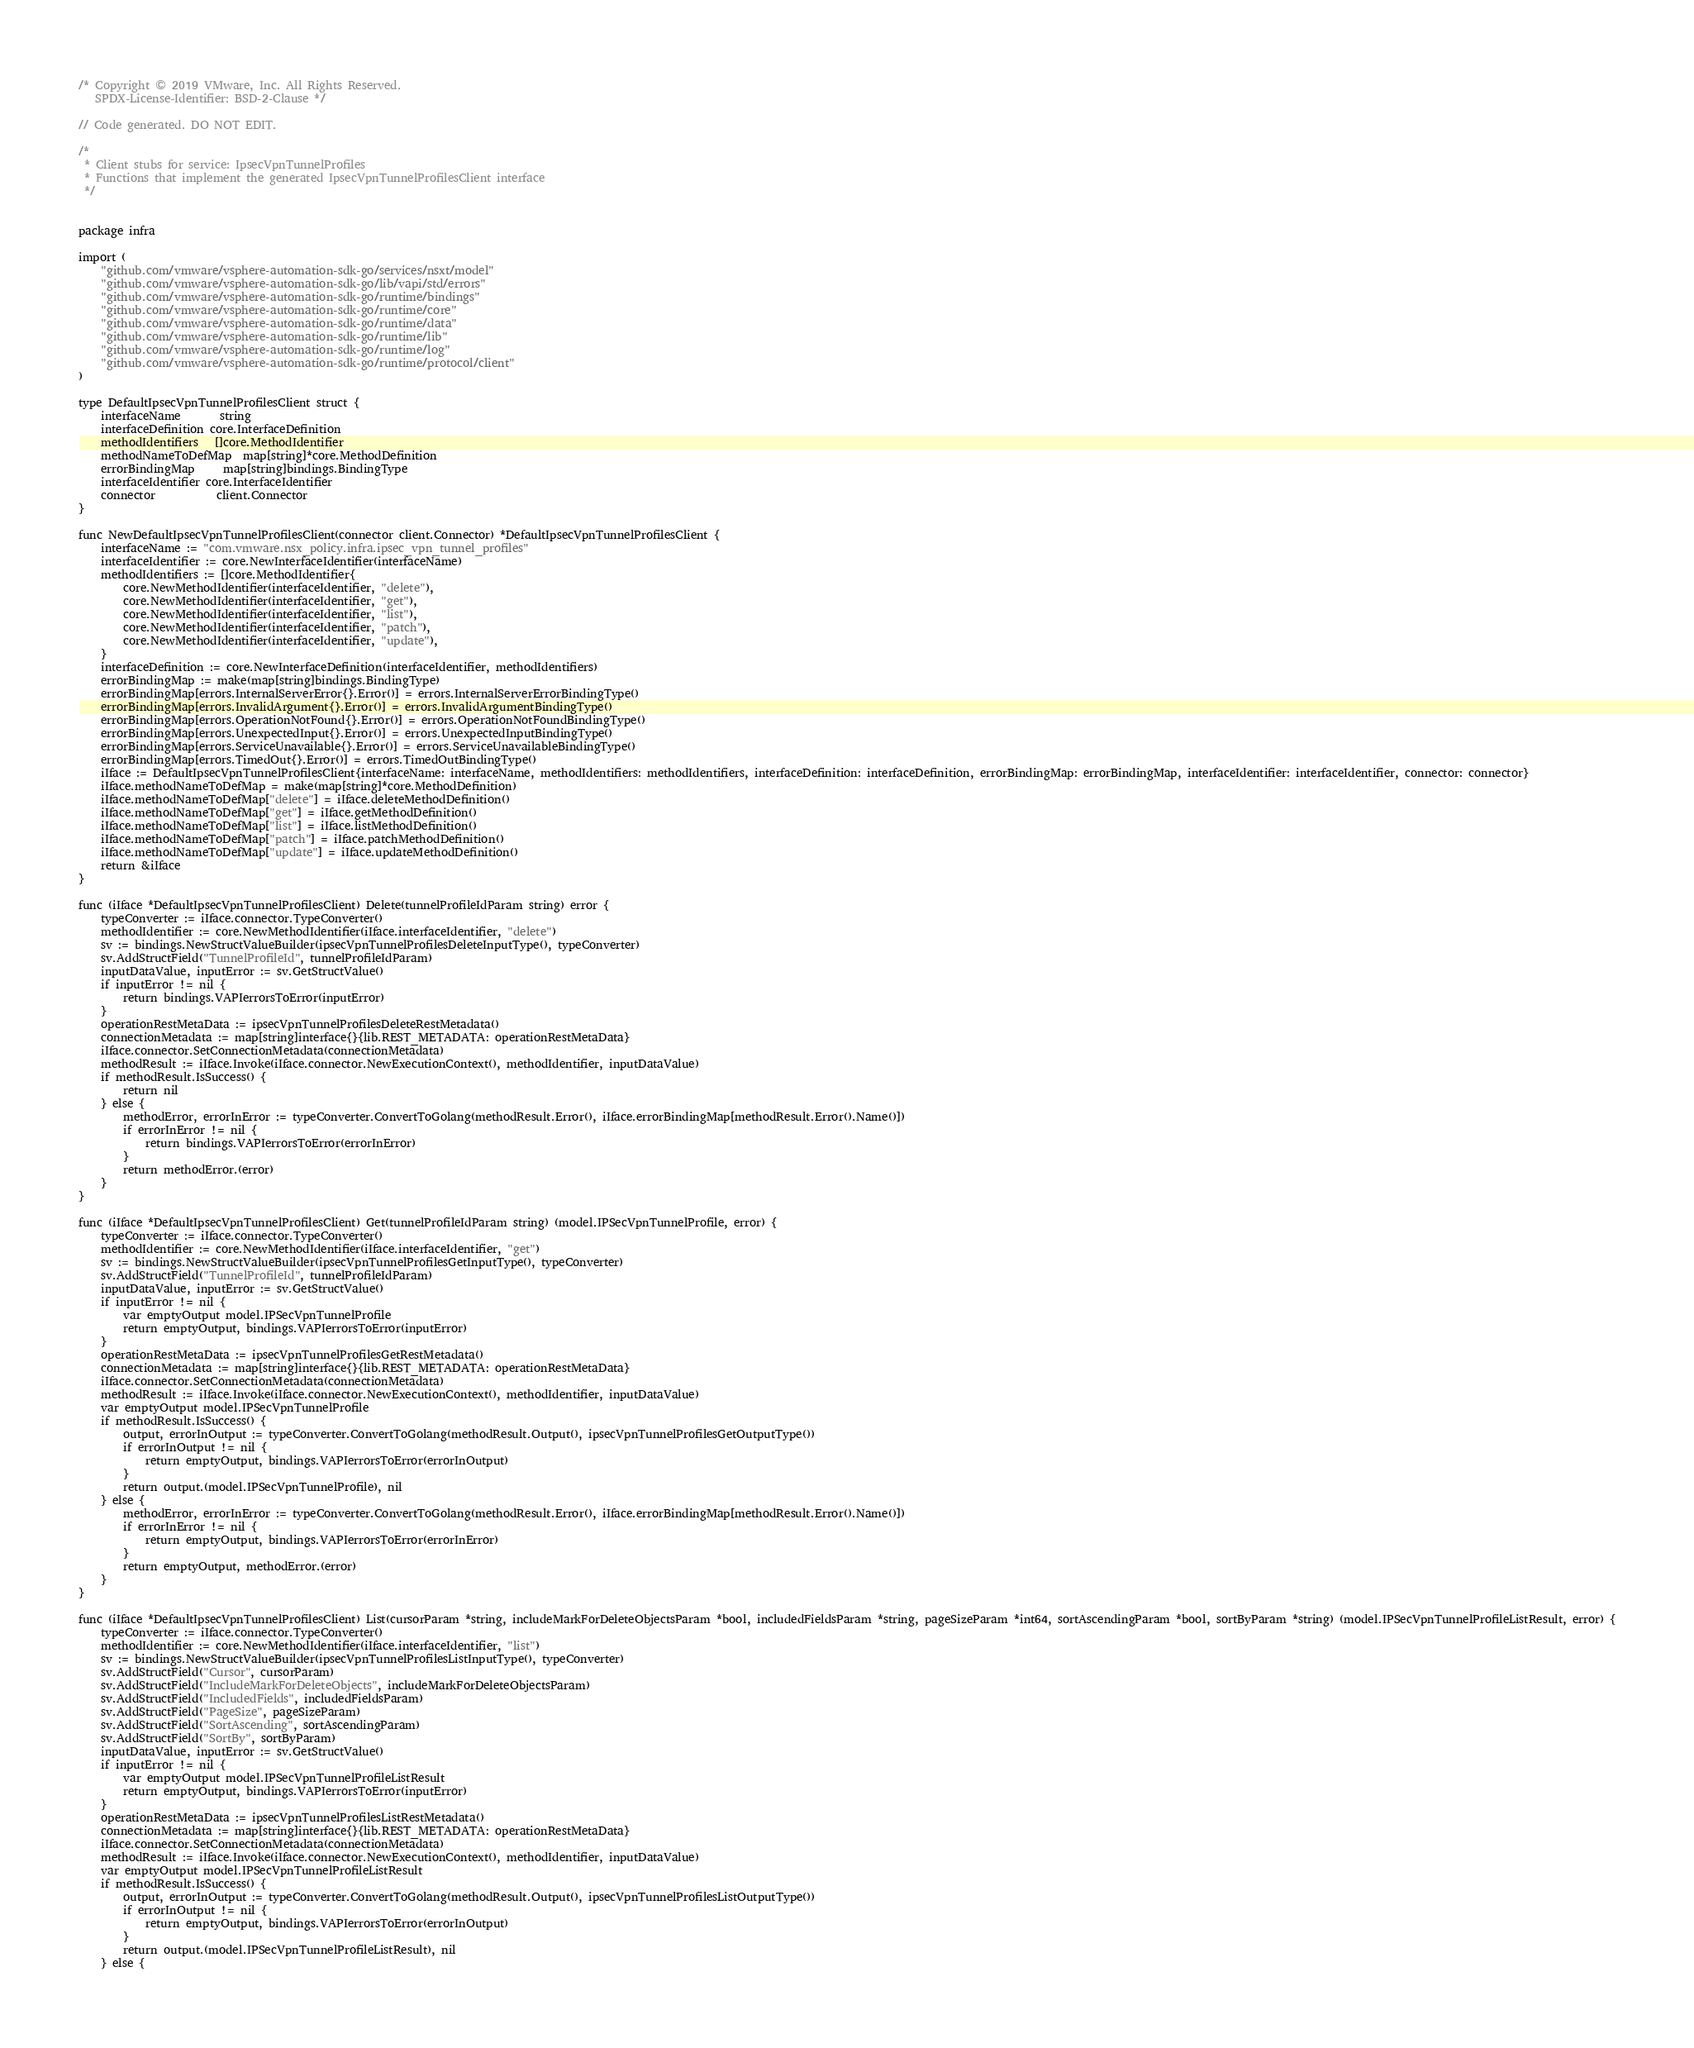Convert code to text. <code><loc_0><loc_0><loc_500><loc_500><_Go_>
/* Copyright © 2019 VMware, Inc. All Rights Reserved.
   SPDX-License-Identifier: BSD-2-Clause */

// Code generated. DO NOT EDIT.

/*
 * Client stubs for service: IpsecVpnTunnelProfiles
 * Functions that implement the generated IpsecVpnTunnelProfilesClient interface
 */


package infra

import (
	"github.com/vmware/vsphere-automation-sdk-go/services/nsxt/model"
	"github.com/vmware/vsphere-automation-sdk-go/lib/vapi/std/errors"
	"github.com/vmware/vsphere-automation-sdk-go/runtime/bindings"
	"github.com/vmware/vsphere-automation-sdk-go/runtime/core"
	"github.com/vmware/vsphere-automation-sdk-go/runtime/data"
	"github.com/vmware/vsphere-automation-sdk-go/runtime/lib"
	"github.com/vmware/vsphere-automation-sdk-go/runtime/log"
	"github.com/vmware/vsphere-automation-sdk-go/runtime/protocol/client"
)

type DefaultIpsecVpnTunnelProfilesClient struct {
	interfaceName       string
	interfaceDefinition core.InterfaceDefinition
	methodIdentifiers   []core.MethodIdentifier
	methodNameToDefMap  map[string]*core.MethodDefinition
	errorBindingMap     map[string]bindings.BindingType
	interfaceIdentifier core.InterfaceIdentifier
	connector           client.Connector
}

func NewDefaultIpsecVpnTunnelProfilesClient(connector client.Connector) *DefaultIpsecVpnTunnelProfilesClient {
	interfaceName := "com.vmware.nsx_policy.infra.ipsec_vpn_tunnel_profiles"
	interfaceIdentifier := core.NewInterfaceIdentifier(interfaceName)
	methodIdentifiers := []core.MethodIdentifier{
		core.NewMethodIdentifier(interfaceIdentifier, "delete"),
		core.NewMethodIdentifier(interfaceIdentifier, "get"),
		core.NewMethodIdentifier(interfaceIdentifier, "list"),
		core.NewMethodIdentifier(interfaceIdentifier, "patch"),
		core.NewMethodIdentifier(interfaceIdentifier, "update"),
	}
	interfaceDefinition := core.NewInterfaceDefinition(interfaceIdentifier, methodIdentifiers)
	errorBindingMap := make(map[string]bindings.BindingType)
	errorBindingMap[errors.InternalServerError{}.Error()] = errors.InternalServerErrorBindingType()
	errorBindingMap[errors.InvalidArgument{}.Error()] = errors.InvalidArgumentBindingType()
	errorBindingMap[errors.OperationNotFound{}.Error()] = errors.OperationNotFoundBindingType()
	errorBindingMap[errors.UnexpectedInput{}.Error()] = errors.UnexpectedInputBindingType()
	errorBindingMap[errors.ServiceUnavailable{}.Error()] = errors.ServiceUnavailableBindingType()
	errorBindingMap[errors.TimedOut{}.Error()] = errors.TimedOutBindingType()
	iIface := DefaultIpsecVpnTunnelProfilesClient{interfaceName: interfaceName, methodIdentifiers: methodIdentifiers, interfaceDefinition: interfaceDefinition, errorBindingMap: errorBindingMap, interfaceIdentifier: interfaceIdentifier, connector: connector}
	iIface.methodNameToDefMap = make(map[string]*core.MethodDefinition)
	iIface.methodNameToDefMap["delete"] = iIface.deleteMethodDefinition()
	iIface.methodNameToDefMap["get"] = iIface.getMethodDefinition()
	iIface.methodNameToDefMap["list"] = iIface.listMethodDefinition()
	iIface.methodNameToDefMap["patch"] = iIface.patchMethodDefinition()
	iIface.methodNameToDefMap["update"] = iIface.updateMethodDefinition()
	return &iIface
}

func (iIface *DefaultIpsecVpnTunnelProfilesClient) Delete(tunnelProfileIdParam string) error {
	typeConverter := iIface.connector.TypeConverter()
	methodIdentifier := core.NewMethodIdentifier(iIface.interfaceIdentifier, "delete")
	sv := bindings.NewStructValueBuilder(ipsecVpnTunnelProfilesDeleteInputType(), typeConverter)
	sv.AddStructField("TunnelProfileId", tunnelProfileIdParam)
	inputDataValue, inputError := sv.GetStructValue()
	if inputError != nil {
		return bindings.VAPIerrorsToError(inputError)
	}
	operationRestMetaData := ipsecVpnTunnelProfilesDeleteRestMetadata()
	connectionMetadata := map[string]interface{}{lib.REST_METADATA: operationRestMetaData}
	iIface.connector.SetConnectionMetadata(connectionMetadata)
	methodResult := iIface.Invoke(iIface.connector.NewExecutionContext(), methodIdentifier, inputDataValue)
	if methodResult.IsSuccess() {
		return nil
	} else {
		methodError, errorInError := typeConverter.ConvertToGolang(methodResult.Error(), iIface.errorBindingMap[methodResult.Error().Name()])
		if errorInError != nil {
			return bindings.VAPIerrorsToError(errorInError)
		}
		return methodError.(error)
	}
}

func (iIface *DefaultIpsecVpnTunnelProfilesClient) Get(tunnelProfileIdParam string) (model.IPSecVpnTunnelProfile, error) {
	typeConverter := iIface.connector.TypeConverter()
	methodIdentifier := core.NewMethodIdentifier(iIface.interfaceIdentifier, "get")
	sv := bindings.NewStructValueBuilder(ipsecVpnTunnelProfilesGetInputType(), typeConverter)
	sv.AddStructField("TunnelProfileId", tunnelProfileIdParam)
	inputDataValue, inputError := sv.GetStructValue()
	if inputError != nil {
		var emptyOutput model.IPSecVpnTunnelProfile
		return emptyOutput, bindings.VAPIerrorsToError(inputError)
	}
	operationRestMetaData := ipsecVpnTunnelProfilesGetRestMetadata()
	connectionMetadata := map[string]interface{}{lib.REST_METADATA: operationRestMetaData}
	iIface.connector.SetConnectionMetadata(connectionMetadata)
	methodResult := iIface.Invoke(iIface.connector.NewExecutionContext(), methodIdentifier, inputDataValue)
	var emptyOutput model.IPSecVpnTunnelProfile
	if methodResult.IsSuccess() {
		output, errorInOutput := typeConverter.ConvertToGolang(methodResult.Output(), ipsecVpnTunnelProfilesGetOutputType())
		if errorInOutput != nil {
			return emptyOutput, bindings.VAPIerrorsToError(errorInOutput)
		}
		return output.(model.IPSecVpnTunnelProfile), nil
	} else {
		methodError, errorInError := typeConverter.ConvertToGolang(methodResult.Error(), iIface.errorBindingMap[methodResult.Error().Name()])
		if errorInError != nil {
			return emptyOutput, bindings.VAPIerrorsToError(errorInError)
		}
		return emptyOutput, methodError.(error)
	}
}

func (iIface *DefaultIpsecVpnTunnelProfilesClient) List(cursorParam *string, includeMarkForDeleteObjectsParam *bool, includedFieldsParam *string, pageSizeParam *int64, sortAscendingParam *bool, sortByParam *string) (model.IPSecVpnTunnelProfileListResult, error) {
	typeConverter := iIface.connector.TypeConverter()
	methodIdentifier := core.NewMethodIdentifier(iIface.interfaceIdentifier, "list")
	sv := bindings.NewStructValueBuilder(ipsecVpnTunnelProfilesListInputType(), typeConverter)
	sv.AddStructField("Cursor", cursorParam)
	sv.AddStructField("IncludeMarkForDeleteObjects", includeMarkForDeleteObjectsParam)
	sv.AddStructField("IncludedFields", includedFieldsParam)
	sv.AddStructField("PageSize", pageSizeParam)
	sv.AddStructField("SortAscending", sortAscendingParam)
	sv.AddStructField("SortBy", sortByParam)
	inputDataValue, inputError := sv.GetStructValue()
	if inputError != nil {
		var emptyOutput model.IPSecVpnTunnelProfileListResult
		return emptyOutput, bindings.VAPIerrorsToError(inputError)
	}
	operationRestMetaData := ipsecVpnTunnelProfilesListRestMetadata()
	connectionMetadata := map[string]interface{}{lib.REST_METADATA: operationRestMetaData}
	iIface.connector.SetConnectionMetadata(connectionMetadata)
	methodResult := iIface.Invoke(iIface.connector.NewExecutionContext(), methodIdentifier, inputDataValue)
	var emptyOutput model.IPSecVpnTunnelProfileListResult
	if methodResult.IsSuccess() {
		output, errorInOutput := typeConverter.ConvertToGolang(methodResult.Output(), ipsecVpnTunnelProfilesListOutputType())
		if errorInOutput != nil {
			return emptyOutput, bindings.VAPIerrorsToError(errorInOutput)
		}
		return output.(model.IPSecVpnTunnelProfileListResult), nil
	} else {</code> 